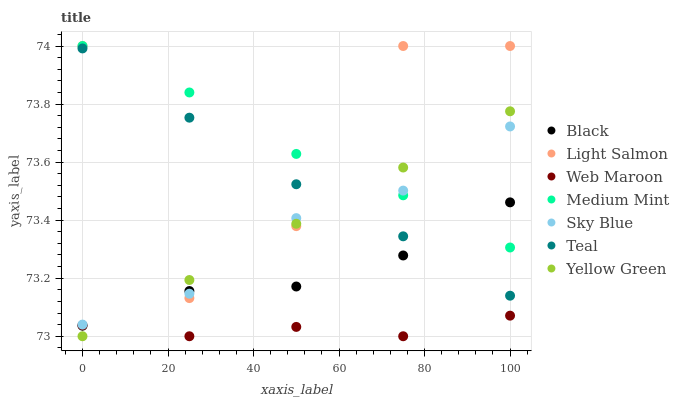Does Web Maroon have the minimum area under the curve?
Answer yes or no. Yes. Does Medium Mint have the maximum area under the curve?
Answer yes or no. Yes. Does Light Salmon have the minimum area under the curve?
Answer yes or no. No. Does Light Salmon have the maximum area under the curve?
Answer yes or no. No. Is Yellow Green the smoothest?
Answer yes or no. Yes. Is Light Salmon the roughest?
Answer yes or no. Yes. Is Light Salmon the smoothest?
Answer yes or no. No. Is Yellow Green the roughest?
Answer yes or no. No. Does Yellow Green have the lowest value?
Answer yes or no. Yes. Does Light Salmon have the lowest value?
Answer yes or no. No. Does Light Salmon have the highest value?
Answer yes or no. Yes. Does Yellow Green have the highest value?
Answer yes or no. No. Is Web Maroon less than Teal?
Answer yes or no. Yes. Is Medium Mint greater than Teal?
Answer yes or no. Yes. Does Light Salmon intersect Teal?
Answer yes or no. Yes. Is Light Salmon less than Teal?
Answer yes or no. No. Is Light Salmon greater than Teal?
Answer yes or no. No. Does Web Maroon intersect Teal?
Answer yes or no. No. 